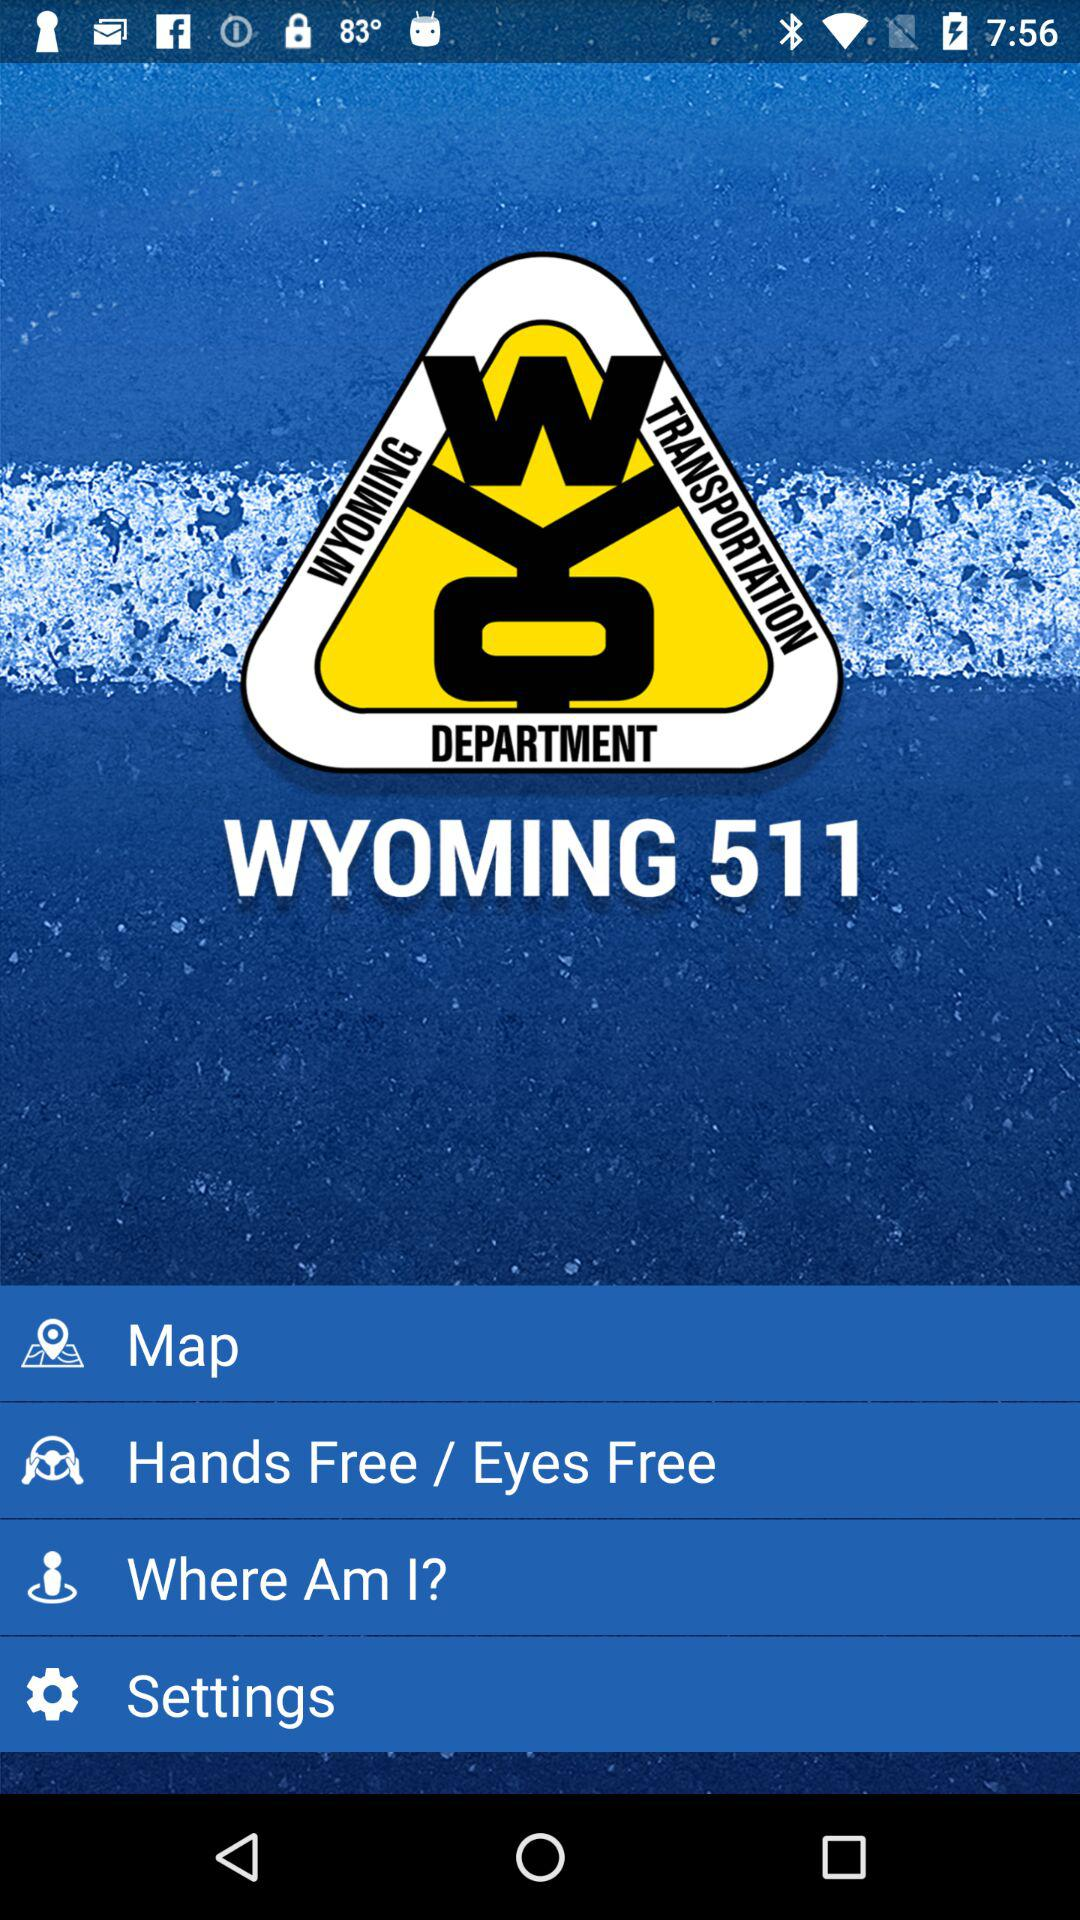How many items have a text label?
Answer the question using a single word or phrase. 4 